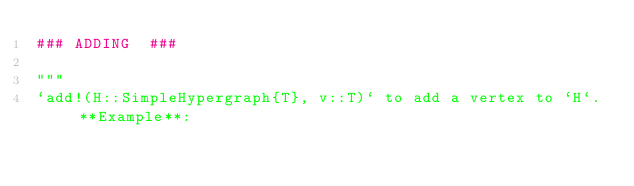Convert code to text. <code><loc_0><loc_0><loc_500><loc_500><_Julia_>### ADDING  ###

"""
`add!(H::SimpleHypergraph{T}, v::T)` to add a vertex to `H`. **Example**:</code> 